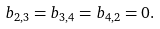Convert formula to latex. <formula><loc_0><loc_0><loc_500><loc_500>b _ { 2 , 3 } = b _ { 3 , 4 } = b _ { 4 , 2 } = 0 .</formula> 